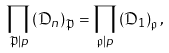Convert formula to latex. <formula><loc_0><loc_0><loc_500><loc_500>\prod _ { \mathfrak { P } | p } \left ( \mathfrak { D } _ { n } \right ) _ { \mathfrak { P } } = \prod _ { \mathfrak { p } | p } \left ( \mathfrak { D } _ { 1 } \right ) _ { \mathfrak { p } } ,</formula> 